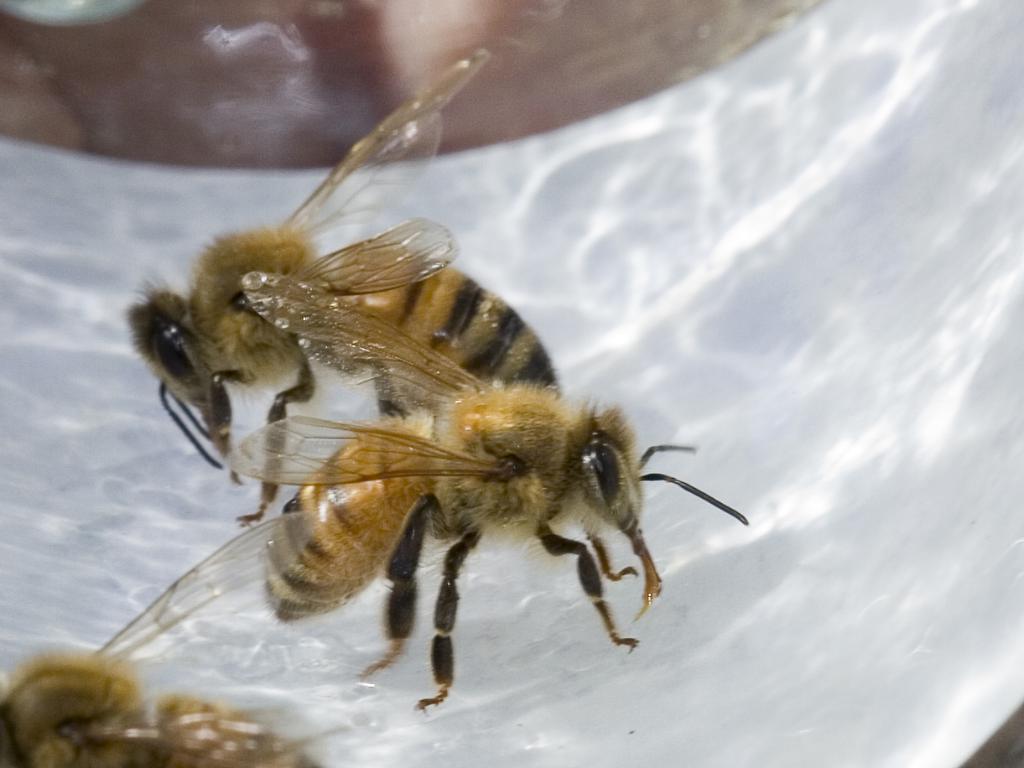How would you summarize this image in a sentence or two? In this image in the center there are some bees, and at bottom there is a white substance. 